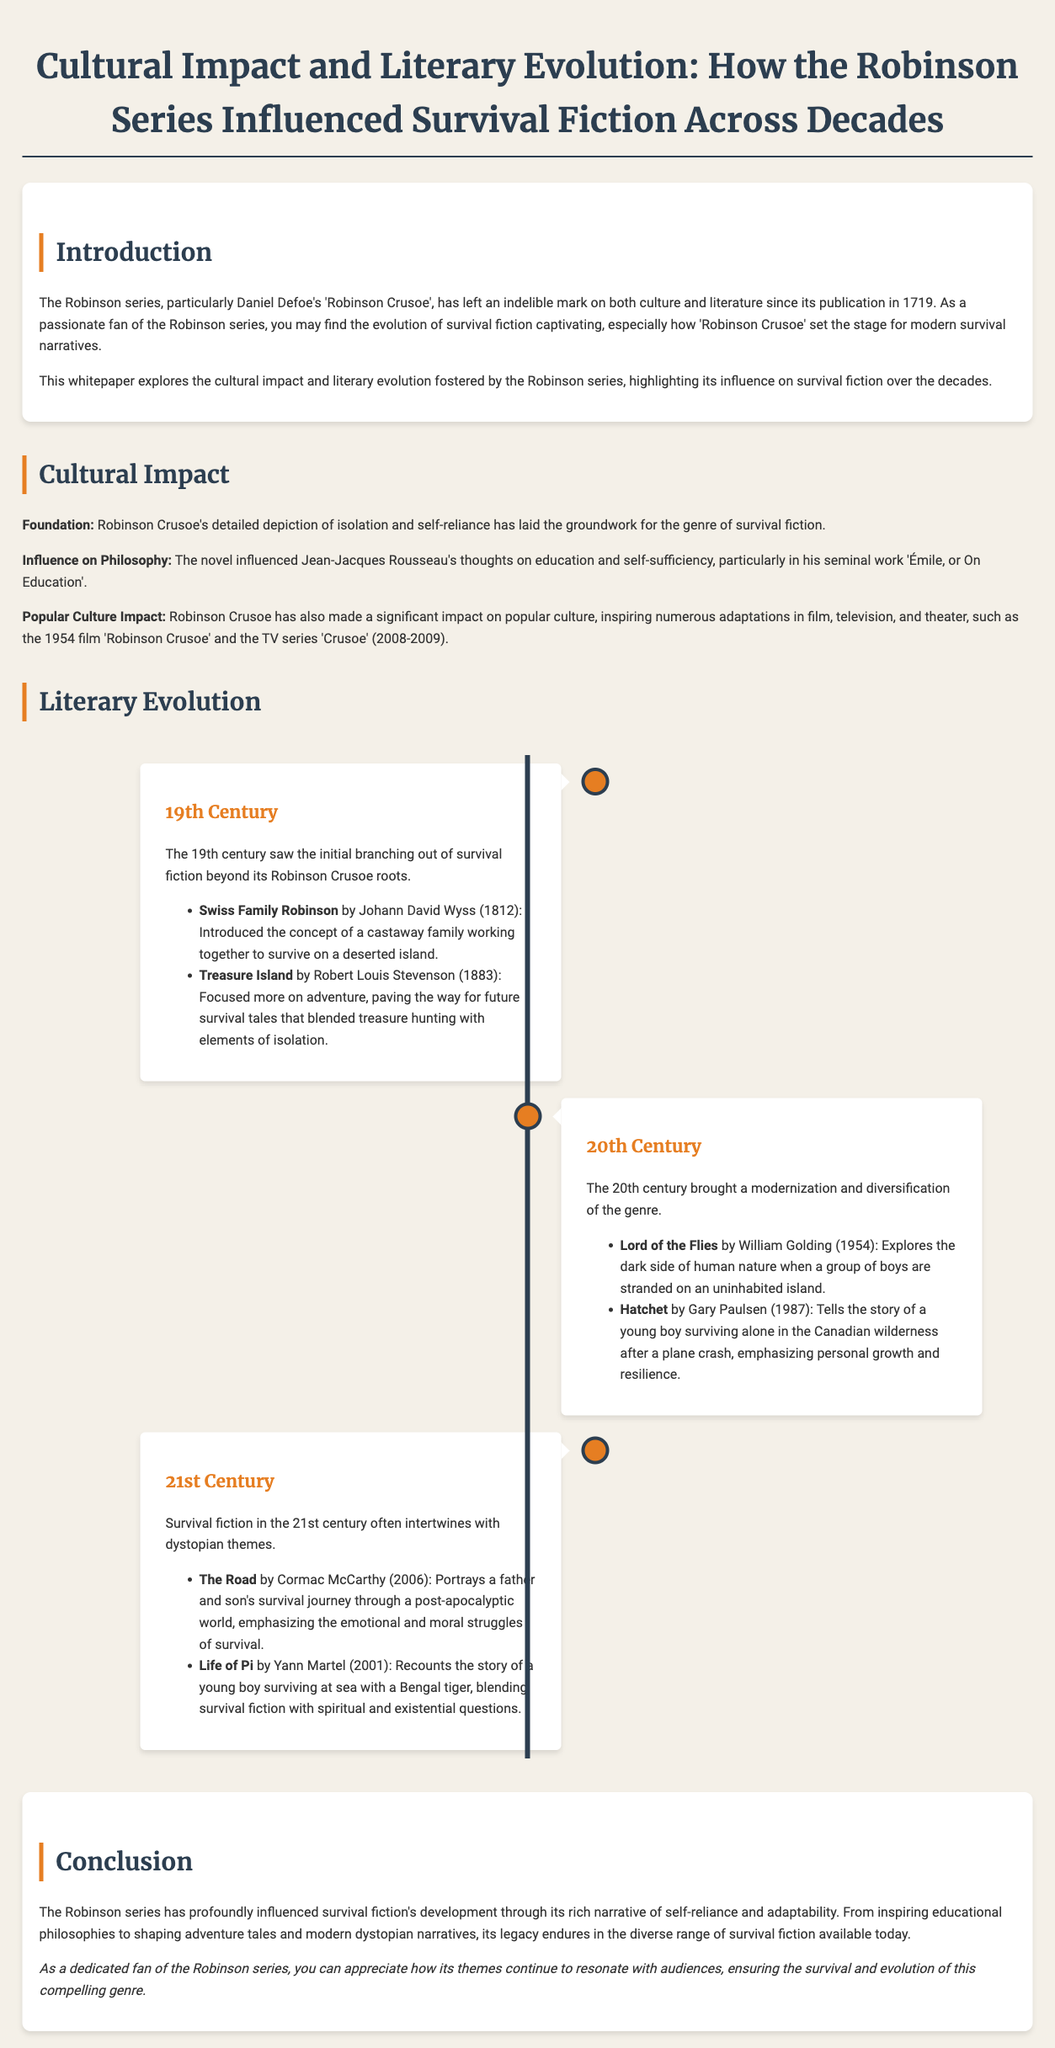What year was 'Robinson Crusoe' published? 'Robinson Crusoe' was published in 1719.
Answer: 1719 Who wrote 'Swiss Family Robinson'? 'Swiss Family Robinson' was written by Johann David Wyss.
Answer: Johann David Wyss What theme does 'Life of Pi' blend with survival fiction? 'Life of Pi' blends survival fiction with spiritual and existential questions.
Answer: Spiritual and existential questions Which novel explores the dark side of human nature? 'Lord of the Flies' explores the dark side of human nature.
Answer: Lord of the Flies What significant cultural figure's thoughts were influenced by 'Robinson Crusoe'? Jean-Jacques Rousseau's thoughts were influenced by 'Robinson Crusoe'.
Answer: Jean-Jacques Rousseau What century saw the introduction of 'Hatchet'? 'Hatchet' was introduced in the 20th century.
Answer: 20th century What is a defining characteristic of survival fiction in the 21st century? Survival fiction in the 21st century often intertwines with dystopian themes.
Answer: Dystopian themes How does the whitepaper describe the legacy of the Robinson series? The whitepaper describes the legacy as enduring in the diverse range of survival fiction.
Answer: Enduring What structure does the document use to outline literary evolution? The document uses a timeline structure to outline literary evolution.
Answer: Timeline structure 